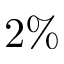<formula> <loc_0><loc_0><loc_500><loc_500>2 \%</formula> 